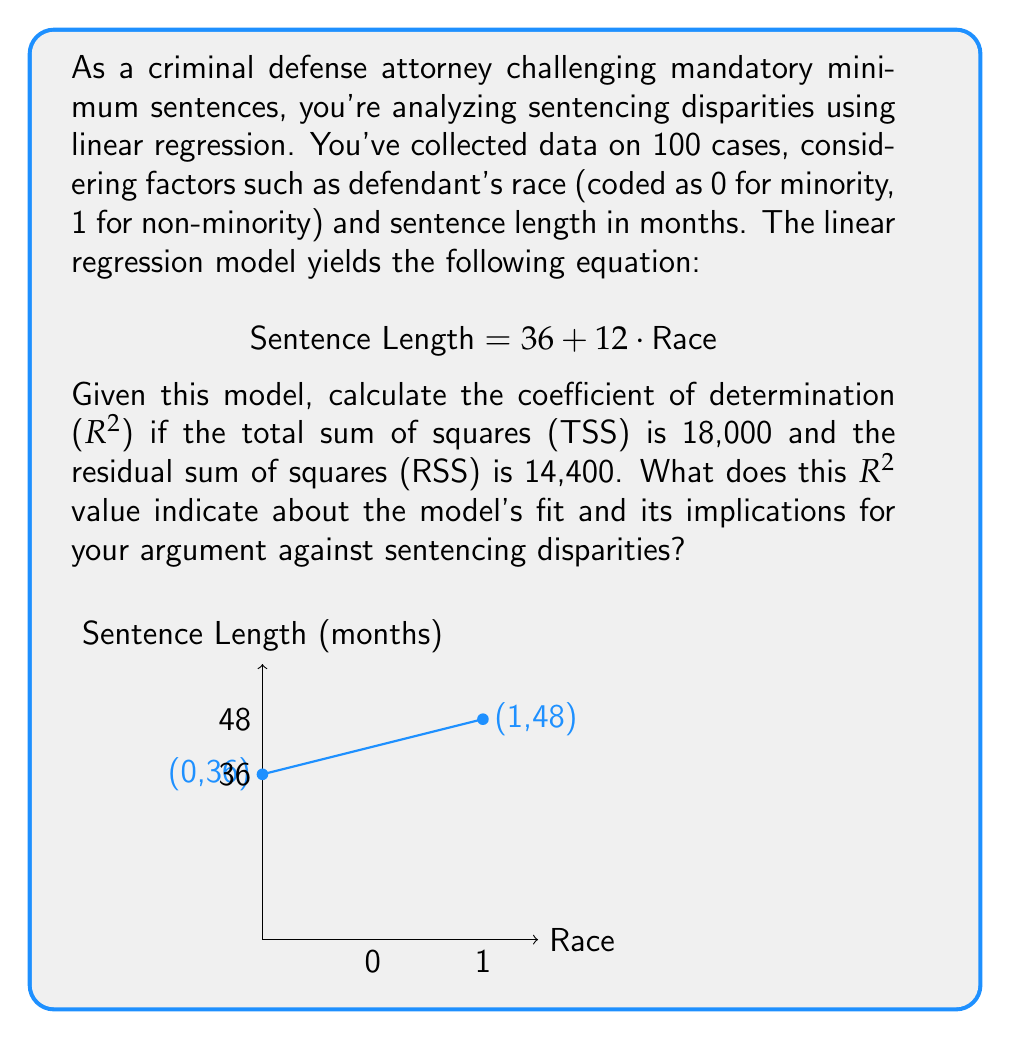Can you answer this question? To solve this problem, let's break it down into steps:

1) The coefficient of determination ($R^2$) is calculated using the formula:

   $$ R^2 = 1 - \frac{\text{RSS}}{\text{TSS}} $$

   Where RSS is the Residual Sum of Squares and TSS is the Total Sum of Squares.

2) We're given that TSS = 18,000 and RSS = 14,400. Let's plug these into the formula:

   $$ R^2 = 1 - \frac{14,400}{18,000} $$

3) Simplify:
   $$ R^2 = 1 - 0.8 = 0.2 $$

4) Interpretation:
   - $R^2$ ranges from 0 to 1, where 1 indicates a perfect fit.
   - An $R^2$ of 0.2 means that 20% of the variability in sentence length is explained by the race factor in this model.
   - This low $R^2$ suggests that while race does have some impact on sentencing, it's not the only or even the primary factor.

5) Implications for challenging mandatory minimums:
   - The model shows a 12-month increase in sentence length for non-minorities, which is concerning.
   - However, the low $R^2$ indicates that other factors not included in this simple model are likely influencing sentencing disparities.
   - This supports an argument that mandatory minimums may be overly simplistic and fail to account for the complexity of factors influencing sentencing.
Answer: $R^2 = 0.2$, indicating a weak fit and suggesting that while race impacts sentencing, other factors not in the model likely play significant roles in sentencing disparities. 